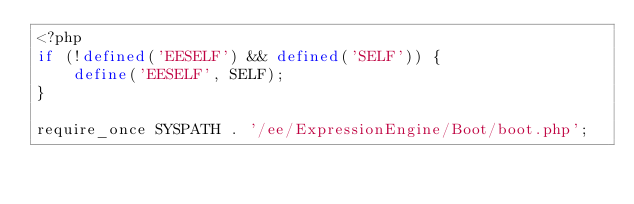<code> <loc_0><loc_0><loc_500><loc_500><_PHP_><?php
if (!defined('EESELF') && defined('SELF')) {
    define('EESELF', SELF);
}

require_once SYSPATH . '/ee/ExpressionEngine/Boot/boot.php';
</code> 